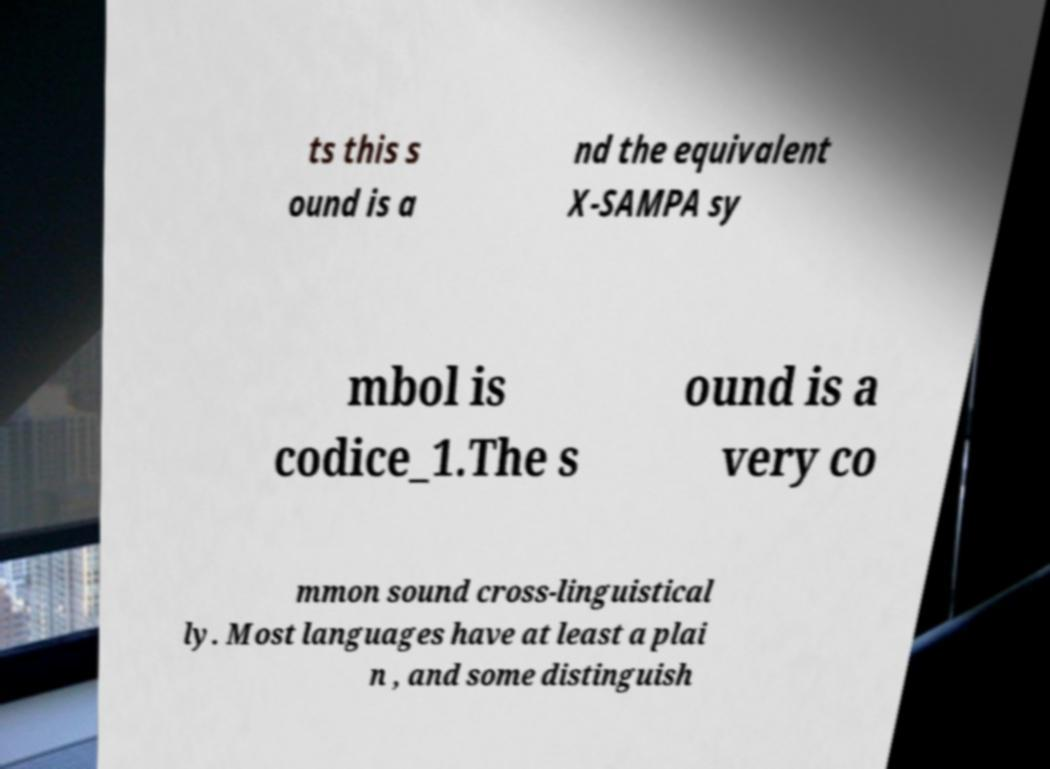Please read and relay the text visible in this image. What does it say? ts this s ound is a nd the equivalent X-SAMPA sy mbol is codice_1.The s ound is a very co mmon sound cross-linguistical ly. Most languages have at least a plai n , and some distinguish 